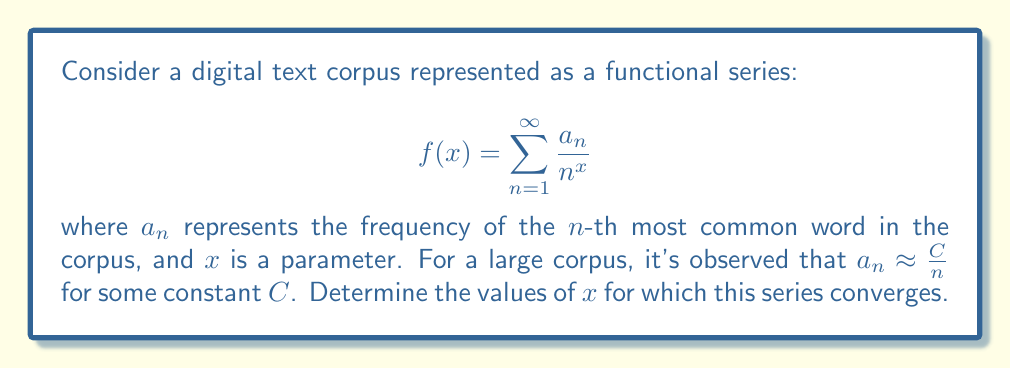Give your solution to this math problem. To analyze the convergence of this functional series, we'll follow these steps:

1) First, we substitute the approximation $a_n \approx \frac{C}{n}$ into our series:

   $$f(x) \approx \sum_{n=1}^{\infty} \frac{C/n}{n^x} = C\sum_{n=1}^{\infty} \frac{1}{n^{x+1}}$$

2) We recognize this as a multiple of the Riemann zeta function $\zeta(s)$ where $s = x+1$:

   $$f(x) \approx C\zeta(x+1)$$

3) The Riemann zeta function converges for all $s > 1$. Therefore, our series will converge when:

   $$x + 1 > 1$$
   $$x > 0$$

4) However, we need to be cautious about the approximation we used. The original series might have slightly different convergence properties. To be more rigorous, we can use the limit comparison test with our approximation:

   $$\lim_{n \to \infty} \frac{a_n/n^x}{C/(n^{x+1})} = \lim_{n \to \infty} \frac{a_n n}{C} = 1$$

   This limit exists and is finite, confirming that our original series converges for the same values of $x$ as our approximation.

5) Therefore, we can conclude that the series converges for all $x > 0$.

This result has an interesting interpretation in the context of digital humanities: it suggests that the "weight" of words in the corpus (represented by $1/n^x$) needs to decrease faster than their frequency ($a_n$) increases for the series to converge, which occurs when $x > 0$.
Answer: The functional series converges for all $x > 0$. 